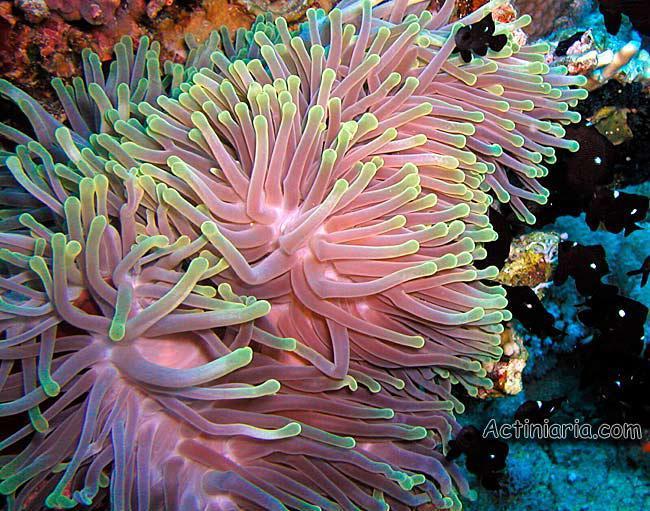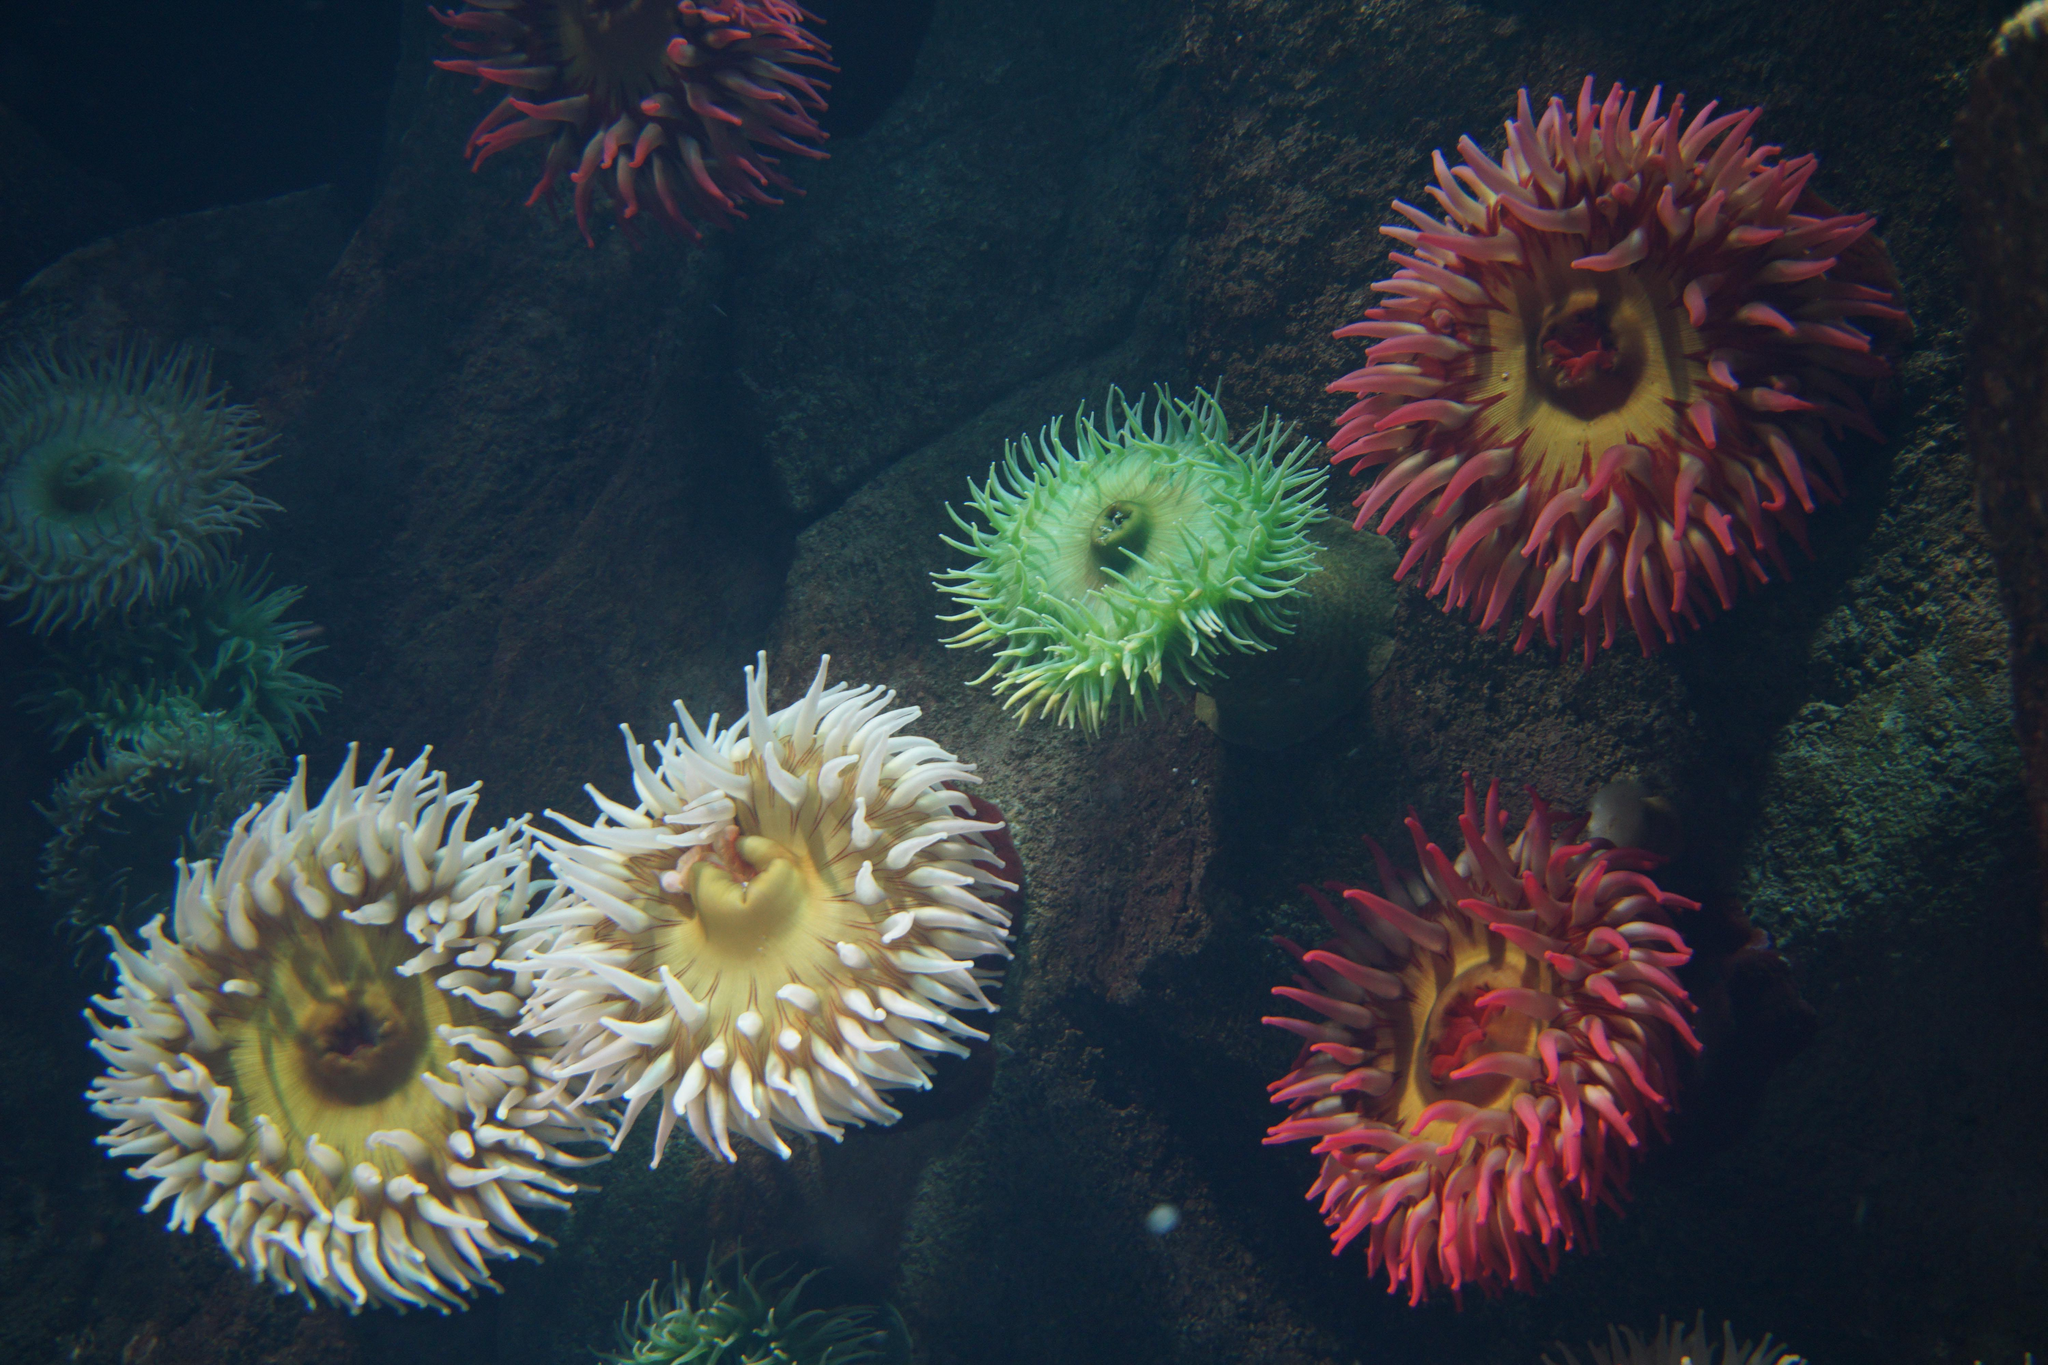The first image is the image on the left, the second image is the image on the right. Evaluate the accuracy of this statement regarding the images: "One image features a single jellyfish with spiky, non-rounded tendrils that are two-toned in white and another color.". Is it true? Answer yes or no. No. The first image is the image on the left, the second image is the image on the right. For the images shown, is this caption "There are two white anemones." true? Answer yes or no. Yes. 